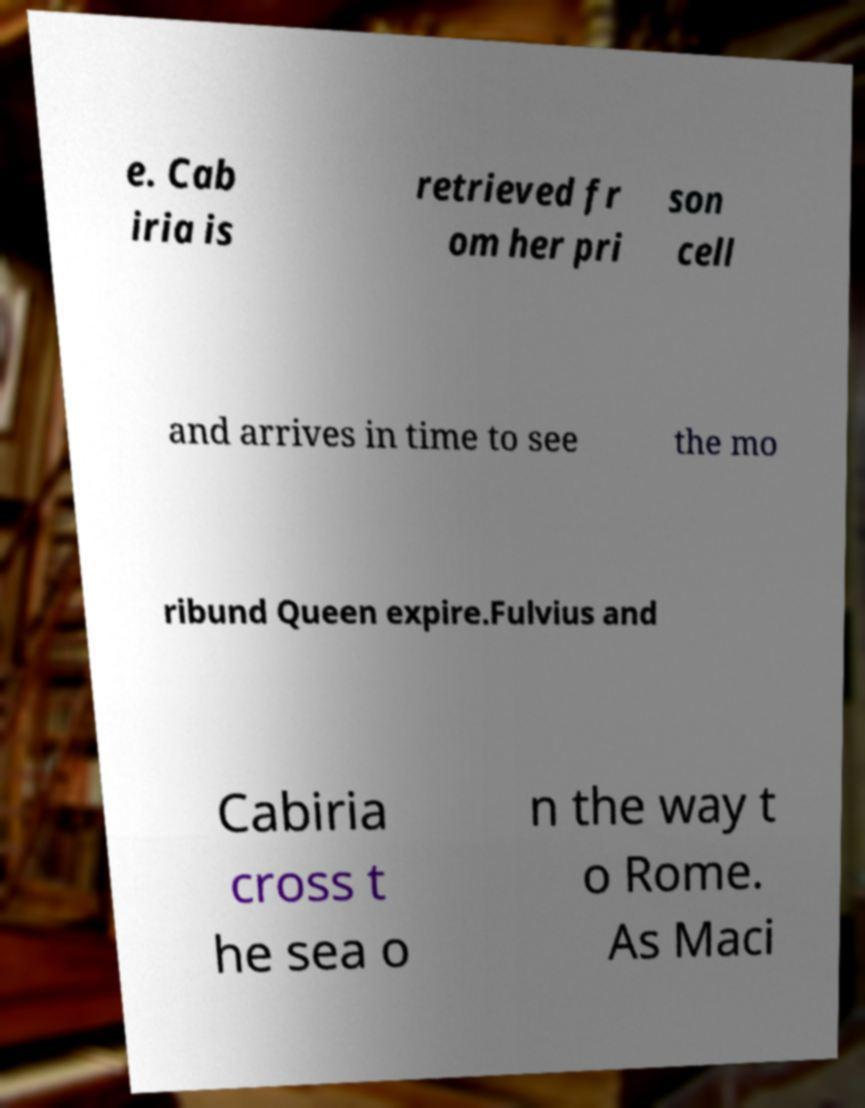Can you read and provide the text displayed in the image?This photo seems to have some interesting text. Can you extract and type it out for me? e. Cab iria is retrieved fr om her pri son cell and arrives in time to see the mo ribund Queen expire.Fulvius and Cabiria cross t he sea o n the way t o Rome. As Maci 